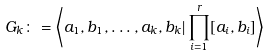<formula> <loc_0><loc_0><loc_500><loc_500>G _ { k } \colon = \left \langle a _ { 1 } , b _ { 1 } , \dots , a _ { k } , b _ { k } | \prod _ { i = 1 } ^ { r } [ a _ { i } , b _ { i } ] \right \rangle</formula> 